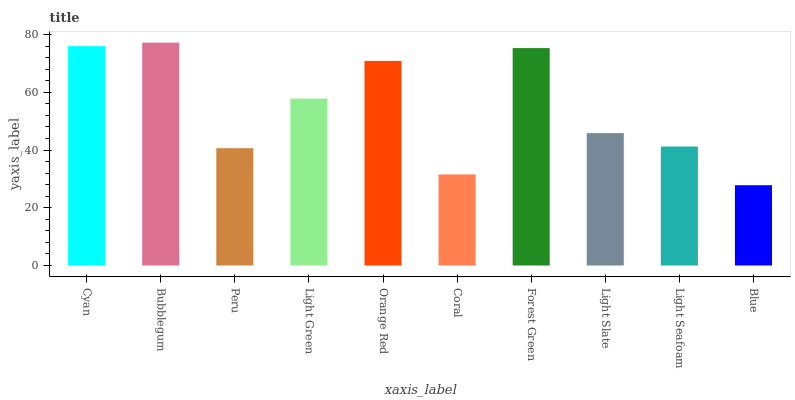Is Blue the minimum?
Answer yes or no. Yes. Is Bubblegum the maximum?
Answer yes or no. Yes. Is Peru the minimum?
Answer yes or no. No. Is Peru the maximum?
Answer yes or no. No. Is Bubblegum greater than Peru?
Answer yes or no. Yes. Is Peru less than Bubblegum?
Answer yes or no. Yes. Is Peru greater than Bubblegum?
Answer yes or no. No. Is Bubblegum less than Peru?
Answer yes or no. No. Is Light Green the high median?
Answer yes or no. Yes. Is Light Slate the low median?
Answer yes or no. Yes. Is Cyan the high median?
Answer yes or no. No. Is Orange Red the low median?
Answer yes or no. No. 